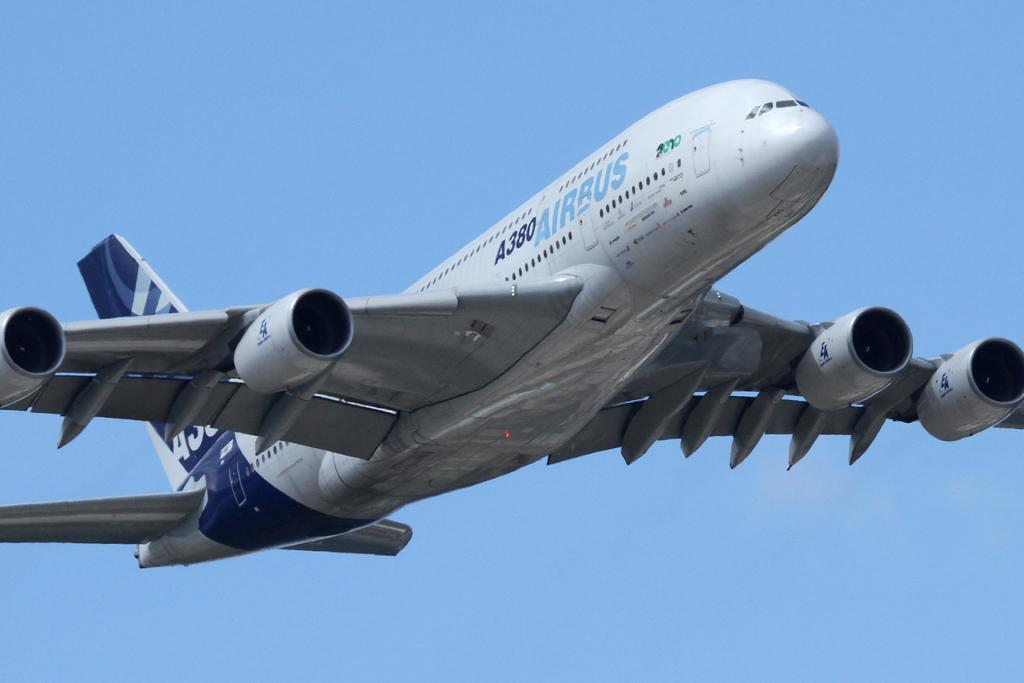<image>
Create a compact narrative representing the image presented. a giant plane flying with the word Airbus on it 